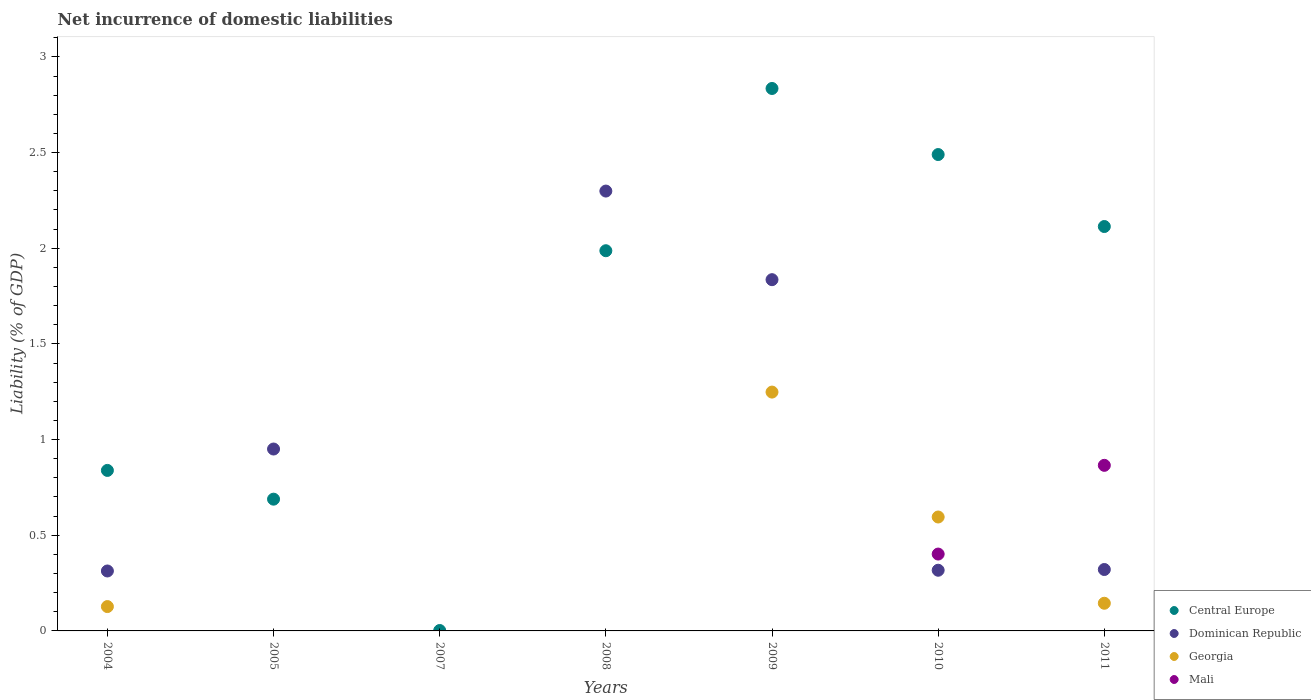What is the net incurrence of domestic liabilities in Dominican Republic in 2008?
Offer a terse response. 2.3. Across all years, what is the maximum net incurrence of domestic liabilities in Central Europe?
Provide a short and direct response. 2.83. Across all years, what is the minimum net incurrence of domestic liabilities in Central Europe?
Your answer should be very brief. 0. In which year was the net incurrence of domestic liabilities in Central Europe maximum?
Your response must be concise. 2009. What is the total net incurrence of domestic liabilities in Georgia in the graph?
Provide a succinct answer. 2.12. What is the difference between the net incurrence of domestic liabilities in Central Europe in 2005 and that in 2010?
Offer a very short reply. -1.8. What is the difference between the net incurrence of domestic liabilities in Central Europe in 2009 and the net incurrence of domestic liabilities in Dominican Republic in 2008?
Your answer should be very brief. 0.54. What is the average net incurrence of domestic liabilities in Georgia per year?
Ensure brevity in your answer.  0.3. In the year 2011, what is the difference between the net incurrence of domestic liabilities in Georgia and net incurrence of domestic liabilities in Dominican Republic?
Make the answer very short. -0.18. What is the ratio of the net incurrence of domestic liabilities in Central Europe in 2007 to that in 2009?
Give a very brief answer. 0. Is the net incurrence of domestic liabilities in Georgia in 2010 less than that in 2011?
Offer a terse response. No. Is the difference between the net incurrence of domestic liabilities in Georgia in 2009 and 2010 greater than the difference between the net incurrence of domestic liabilities in Dominican Republic in 2009 and 2010?
Give a very brief answer. No. What is the difference between the highest and the second highest net incurrence of domestic liabilities in Dominican Republic?
Provide a succinct answer. 0.46. What is the difference between the highest and the lowest net incurrence of domestic liabilities in Central Europe?
Offer a very short reply. 2.83. In how many years, is the net incurrence of domestic liabilities in Central Europe greater than the average net incurrence of domestic liabilities in Central Europe taken over all years?
Make the answer very short. 4. Does the net incurrence of domestic liabilities in Georgia monotonically increase over the years?
Offer a terse response. No. Is the net incurrence of domestic liabilities in Mali strictly greater than the net incurrence of domestic liabilities in Georgia over the years?
Provide a succinct answer. No. How many dotlines are there?
Ensure brevity in your answer.  4. What is the difference between two consecutive major ticks on the Y-axis?
Your answer should be compact. 0.5. Does the graph contain any zero values?
Your answer should be very brief. Yes. Does the graph contain grids?
Your answer should be very brief. No. Where does the legend appear in the graph?
Your answer should be very brief. Bottom right. How many legend labels are there?
Offer a terse response. 4. What is the title of the graph?
Provide a short and direct response. Net incurrence of domestic liabilities. What is the label or title of the Y-axis?
Ensure brevity in your answer.  Liability (% of GDP). What is the Liability (% of GDP) of Central Europe in 2004?
Make the answer very short. 0.84. What is the Liability (% of GDP) of Dominican Republic in 2004?
Ensure brevity in your answer.  0.31. What is the Liability (% of GDP) in Georgia in 2004?
Offer a very short reply. 0.13. What is the Liability (% of GDP) of Mali in 2004?
Your answer should be very brief. 0. What is the Liability (% of GDP) of Central Europe in 2005?
Your response must be concise. 0.69. What is the Liability (% of GDP) of Dominican Republic in 2005?
Your answer should be compact. 0.95. What is the Liability (% of GDP) of Georgia in 2005?
Offer a terse response. 0. What is the Liability (% of GDP) in Mali in 2005?
Provide a short and direct response. 0. What is the Liability (% of GDP) of Central Europe in 2007?
Offer a very short reply. 0. What is the Liability (% of GDP) in Georgia in 2007?
Keep it short and to the point. 0. What is the Liability (% of GDP) of Mali in 2007?
Your response must be concise. 0. What is the Liability (% of GDP) of Central Europe in 2008?
Keep it short and to the point. 1.99. What is the Liability (% of GDP) of Dominican Republic in 2008?
Offer a terse response. 2.3. What is the Liability (% of GDP) in Georgia in 2008?
Your answer should be very brief. 0. What is the Liability (% of GDP) of Mali in 2008?
Your answer should be compact. 0. What is the Liability (% of GDP) of Central Europe in 2009?
Provide a short and direct response. 2.83. What is the Liability (% of GDP) of Dominican Republic in 2009?
Your answer should be very brief. 1.84. What is the Liability (% of GDP) of Georgia in 2009?
Ensure brevity in your answer.  1.25. What is the Liability (% of GDP) of Central Europe in 2010?
Offer a terse response. 2.49. What is the Liability (% of GDP) of Dominican Republic in 2010?
Offer a very short reply. 0.32. What is the Liability (% of GDP) in Georgia in 2010?
Keep it short and to the point. 0.6. What is the Liability (% of GDP) of Mali in 2010?
Offer a terse response. 0.4. What is the Liability (% of GDP) of Central Europe in 2011?
Your answer should be compact. 2.11. What is the Liability (% of GDP) in Dominican Republic in 2011?
Make the answer very short. 0.32. What is the Liability (% of GDP) of Georgia in 2011?
Provide a short and direct response. 0.14. What is the Liability (% of GDP) of Mali in 2011?
Offer a very short reply. 0.87. Across all years, what is the maximum Liability (% of GDP) of Central Europe?
Your response must be concise. 2.83. Across all years, what is the maximum Liability (% of GDP) in Dominican Republic?
Ensure brevity in your answer.  2.3. Across all years, what is the maximum Liability (% of GDP) of Georgia?
Offer a very short reply. 1.25. Across all years, what is the maximum Liability (% of GDP) of Mali?
Offer a terse response. 0.87. Across all years, what is the minimum Liability (% of GDP) of Central Europe?
Offer a terse response. 0. What is the total Liability (% of GDP) of Central Europe in the graph?
Keep it short and to the point. 10.95. What is the total Liability (% of GDP) in Dominican Republic in the graph?
Offer a terse response. 6.04. What is the total Liability (% of GDP) of Georgia in the graph?
Offer a terse response. 2.12. What is the total Liability (% of GDP) of Mali in the graph?
Your answer should be compact. 1.27. What is the difference between the Liability (% of GDP) of Central Europe in 2004 and that in 2005?
Keep it short and to the point. 0.15. What is the difference between the Liability (% of GDP) in Dominican Republic in 2004 and that in 2005?
Keep it short and to the point. -0.64. What is the difference between the Liability (% of GDP) in Central Europe in 2004 and that in 2007?
Provide a succinct answer. 0.84. What is the difference between the Liability (% of GDP) of Central Europe in 2004 and that in 2008?
Keep it short and to the point. -1.15. What is the difference between the Liability (% of GDP) in Dominican Republic in 2004 and that in 2008?
Provide a succinct answer. -1.99. What is the difference between the Liability (% of GDP) of Central Europe in 2004 and that in 2009?
Give a very brief answer. -2. What is the difference between the Liability (% of GDP) in Dominican Republic in 2004 and that in 2009?
Your response must be concise. -1.52. What is the difference between the Liability (% of GDP) of Georgia in 2004 and that in 2009?
Offer a terse response. -1.12. What is the difference between the Liability (% of GDP) of Central Europe in 2004 and that in 2010?
Keep it short and to the point. -1.65. What is the difference between the Liability (% of GDP) of Dominican Republic in 2004 and that in 2010?
Give a very brief answer. -0. What is the difference between the Liability (% of GDP) of Georgia in 2004 and that in 2010?
Ensure brevity in your answer.  -0.47. What is the difference between the Liability (% of GDP) of Central Europe in 2004 and that in 2011?
Your response must be concise. -1.27. What is the difference between the Liability (% of GDP) in Dominican Republic in 2004 and that in 2011?
Keep it short and to the point. -0.01. What is the difference between the Liability (% of GDP) in Georgia in 2004 and that in 2011?
Your response must be concise. -0.02. What is the difference between the Liability (% of GDP) in Central Europe in 2005 and that in 2007?
Your answer should be compact. 0.69. What is the difference between the Liability (% of GDP) of Central Europe in 2005 and that in 2008?
Provide a succinct answer. -1.3. What is the difference between the Liability (% of GDP) of Dominican Republic in 2005 and that in 2008?
Make the answer very short. -1.35. What is the difference between the Liability (% of GDP) in Central Europe in 2005 and that in 2009?
Make the answer very short. -2.15. What is the difference between the Liability (% of GDP) of Dominican Republic in 2005 and that in 2009?
Your response must be concise. -0.89. What is the difference between the Liability (% of GDP) in Central Europe in 2005 and that in 2010?
Your answer should be compact. -1.8. What is the difference between the Liability (% of GDP) of Dominican Republic in 2005 and that in 2010?
Your answer should be compact. 0.63. What is the difference between the Liability (% of GDP) of Central Europe in 2005 and that in 2011?
Make the answer very short. -1.42. What is the difference between the Liability (% of GDP) in Dominican Republic in 2005 and that in 2011?
Ensure brevity in your answer.  0.63. What is the difference between the Liability (% of GDP) of Central Europe in 2007 and that in 2008?
Ensure brevity in your answer.  -1.98. What is the difference between the Liability (% of GDP) of Central Europe in 2007 and that in 2009?
Your response must be concise. -2.83. What is the difference between the Liability (% of GDP) of Central Europe in 2007 and that in 2010?
Offer a terse response. -2.49. What is the difference between the Liability (% of GDP) of Central Europe in 2007 and that in 2011?
Provide a succinct answer. -2.11. What is the difference between the Liability (% of GDP) of Central Europe in 2008 and that in 2009?
Your answer should be compact. -0.85. What is the difference between the Liability (% of GDP) of Dominican Republic in 2008 and that in 2009?
Ensure brevity in your answer.  0.46. What is the difference between the Liability (% of GDP) in Central Europe in 2008 and that in 2010?
Your answer should be compact. -0.5. What is the difference between the Liability (% of GDP) in Dominican Republic in 2008 and that in 2010?
Make the answer very short. 1.98. What is the difference between the Liability (% of GDP) in Central Europe in 2008 and that in 2011?
Offer a terse response. -0.13. What is the difference between the Liability (% of GDP) in Dominican Republic in 2008 and that in 2011?
Provide a short and direct response. 1.98. What is the difference between the Liability (% of GDP) of Central Europe in 2009 and that in 2010?
Keep it short and to the point. 0.35. What is the difference between the Liability (% of GDP) of Dominican Republic in 2009 and that in 2010?
Make the answer very short. 1.52. What is the difference between the Liability (% of GDP) in Georgia in 2009 and that in 2010?
Provide a succinct answer. 0.65. What is the difference between the Liability (% of GDP) in Central Europe in 2009 and that in 2011?
Provide a succinct answer. 0.72. What is the difference between the Liability (% of GDP) of Dominican Republic in 2009 and that in 2011?
Provide a succinct answer. 1.51. What is the difference between the Liability (% of GDP) in Georgia in 2009 and that in 2011?
Ensure brevity in your answer.  1.1. What is the difference between the Liability (% of GDP) in Central Europe in 2010 and that in 2011?
Give a very brief answer. 0.38. What is the difference between the Liability (% of GDP) of Dominican Republic in 2010 and that in 2011?
Your answer should be compact. -0. What is the difference between the Liability (% of GDP) of Georgia in 2010 and that in 2011?
Offer a very short reply. 0.45. What is the difference between the Liability (% of GDP) in Mali in 2010 and that in 2011?
Offer a very short reply. -0.46. What is the difference between the Liability (% of GDP) of Central Europe in 2004 and the Liability (% of GDP) of Dominican Republic in 2005?
Give a very brief answer. -0.11. What is the difference between the Liability (% of GDP) of Central Europe in 2004 and the Liability (% of GDP) of Dominican Republic in 2008?
Offer a very short reply. -1.46. What is the difference between the Liability (% of GDP) of Central Europe in 2004 and the Liability (% of GDP) of Dominican Republic in 2009?
Ensure brevity in your answer.  -1. What is the difference between the Liability (% of GDP) of Central Europe in 2004 and the Liability (% of GDP) of Georgia in 2009?
Offer a very short reply. -0.41. What is the difference between the Liability (% of GDP) in Dominican Republic in 2004 and the Liability (% of GDP) in Georgia in 2009?
Provide a short and direct response. -0.93. What is the difference between the Liability (% of GDP) of Central Europe in 2004 and the Liability (% of GDP) of Dominican Republic in 2010?
Provide a short and direct response. 0.52. What is the difference between the Liability (% of GDP) of Central Europe in 2004 and the Liability (% of GDP) of Georgia in 2010?
Keep it short and to the point. 0.24. What is the difference between the Liability (% of GDP) in Central Europe in 2004 and the Liability (% of GDP) in Mali in 2010?
Give a very brief answer. 0.44. What is the difference between the Liability (% of GDP) in Dominican Republic in 2004 and the Liability (% of GDP) in Georgia in 2010?
Offer a very short reply. -0.28. What is the difference between the Liability (% of GDP) of Dominican Republic in 2004 and the Liability (% of GDP) of Mali in 2010?
Give a very brief answer. -0.09. What is the difference between the Liability (% of GDP) of Georgia in 2004 and the Liability (% of GDP) of Mali in 2010?
Your answer should be compact. -0.27. What is the difference between the Liability (% of GDP) in Central Europe in 2004 and the Liability (% of GDP) in Dominican Republic in 2011?
Your response must be concise. 0.52. What is the difference between the Liability (% of GDP) in Central Europe in 2004 and the Liability (% of GDP) in Georgia in 2011?
Provide a succinct answer. 0.69. What is the difference between the Liability (% of GDP) of Central Europe in 2004 and the Liability (% of GDP) of Mali in 2011?
Your response must be concise. -0.03. What is the difference between the Liability (% of GDP) of Dominican Republic in 2004 and the Liability (% of GDP) of Georgia in 2011?
Your response must be concise. 0.17. What is the difference between the Liability (% of GDP) in Dominican Republic in 2004 and the Liability (% of GDP) in Mali in 2011?
Make the answer very short. -0.55. What is the difference between the Liability (% of GDP) of Georgia in 2004 and the Liability (% of GDP) of Mali in 2011?
Your response must be concise. -0.74. What is the difference between the Liability (% of GDP) in Central Europe in 2005 and the Liability (% of GDP) in Dominican Republic in 2008?
Make the answer very short. -1.61. What is the difference between the Liability (% of GDP) in Central Europe in 2005 and the Liability (% of GDP) in Dominican Republic in 2009?
Your response must be concise. -1.15. What is the difference between the Liability (% of GDP) in Central Europe in 2005 and the Liability (% of GDP) in Georgia in 2009?
Your response must be concise. -0.56. What is the difference between the Liability (% of GDP) in Dominican Republic in 2005 and the Liability (% of GDP) in Georgia in 2009?
Your answer should be compact. -0.3. What is the difference between the Liability (% of GDP) in Central Europe in 2005 and the Liability (% of GDP) in Dominican Republic in 2010?
Give a very brief answer. 0.37. What is the difference between the Liability (% of GDP) of Central Europe in 2005 and the Liability (% of GDP) of Georgia in 2010?
Give a very brief answer. 0.09. What is the difference between the Liability (% of GDP) of Central Europe in 2005 and the Liability (% of GDP) of Mali in 2010?
Your response must be concise. 0.29. What is the difference between the Liability (% of GDP) of Dominican Republic in 2005 and the Liability (% of GDP) of Georgia in 2010?
Make the answer very short. 0.36. What is the difference between the Liability (% of GDP) in Dominican Republic in 2005 and the Liability (% of GDP) in Mali in 2010?
Provide a short and direct response. 0.55. What is the difference between the Liability (% of GDP) of Central Europe in 2005 and the Liability (% of GDP) of Dominican Republic in 2011?
Your answer should be very brief. 0.37. What is the difference between the Liability (% of GDP) of Central Europe in 2005 and the Liability (% of GDP) of Georgia in 2011?
Your response must be concise. 0.54. What is the difference between the Liability (% of GDP) in Central Europe in 2005 and the Liability (% of GDP) in Mali in 2011?
Keep it short and to the point. -0.18. What is the difference between the Liability (% of GDP) of Dominican Republic in 2005 and the Liability (% of GDP) of Georgia in 2011?
Make the answer very short. 0.81. What is the difference between the Liability (% of GDP) in Dominican Republic in 2005 and the Liability (% of GDP) in Mali in 2011?
Your answer should be compact. 0.09. What is the difference between the Liability (% of GDP) of Central Europe in 2007 and the Liability (% of GDP) of Dominican Republic in 2008?
Your answer should be very brief. -2.3. What is the difference between the Liability (% of GDP) in Central Europe in 2007 and the Liability (% of GDP) in Dominican Republic in 2009?
Provide a short and direct response. -1.83. What is the difference between the Liability (% of GDP) of Central Europe in 2007 and the Liability (% of GDP) of Georgia in 2009?
Offer a terse response. -1.25. What is the difference between the Liability (% of GDP) of Central Europe in 2007 and the Liability (% of GDP) of Dominican Republic in 2010?
Ensure brevity in your answer.  -0.32. What is the difference between the Liability (% of GDP) of Central Europe in 2007 and the Liability (% of GDP) of Georgia in 2010?
Offer a terse response. -0.59. What is the difference between the Liability (% of GDP) of Central Europe in 2007 and the Liability (% of GDP) of Mali in 2010?
Offer a very short reply. -0.4. What is the difference between the Liability (% of GDP) of Central Europe in 2007 and the Liability (% of GDP) of Dominican Republic in 2011?
Your answer should be very brief. -0.32. What is the difference between the Liability (% of GDP) of Central Europe in 2007 and the Liability (% of GDP) of Georgia in 2011?
Make the answer very short. -0.14. What is the difference between the Liability (% of GDP) of Central Europe in 2007 and the Liability (% of GDP) of Mali in 2011?
Offer a terse response. -0.86. What is the difference between the Liability (% of GDP) of Central Europe in 2008 and the Liability (% of GDP) of Dominican Republic in 2009?
Make the answer very short. 0.15. What is the difference between the Liability (% of GDP) of Central Europe in 2008 and the Liability (% of GDP) of Georgia in 2009?
Your response must be concise. 0.74. What is the difference between the Liability (% of GDP) of Dominican Republic in 2008 and the Liability (% of GDP) of Georgia in 2009?
Your response must be concise. 1.05. What is the difference between the Liability (% of GDP) of Central Europe in 2008 and the Liability (% of GDP) of Dominican Republic in 2010?
Your answer should be very brief. 1.67. What is the difference between the Liability (% of GDP) in Central Europe in 2008 and the Liability (% of GDP) in Georgia in 2010?
Keep it short and to the point. 1.39. What is the difference between the Liability (% of GDP) in Central Europe in 2008 and the Liability (% of GDP) in Mali in 2010?
Ensure brevity in your answer.  1.59. What is the difference between the Liability (% of GDP) in Dominican Republic in 2008 and the Liability (% of GDP) in Georgia in 2010?
Provide a succinct answer. 1.7. What is the difference between the Liability (% of GDP) in Dominican Republic in 2008 and the Liability (% of GDP) in Mali in 2010?
Your response must be concise. 1.9. What is the difference between the Liability (% of GDP) in Central Europe in 2008 and the Liability (% of GDP) in Dominican Republic in 2011?
Provide a succinct answer. 1.67. What is the difference between the Liability (% of GDP) of Central Europe in 2008 and the Liability (% of GDP) of Georgia in 2011?
Keep it short and to the point. 1.84. What is the difference between the Liability (% of GDP) in Central Europe in 2008 and the Liability (% of GDP) in Mali in 2011?
Ensure brevity in your answer.  1.12. What is the difference between the Liability (% of GDP) in Dominican Republic in 2008 and the Liability (% of GDP) in Georgia in 2011?
Provide a succinct answer. 2.15. What is the difference between the Liability (% of GDP) in Dominican Republic in 2008 and the Liability (% of GDP) in Mali in 2011?
Give a very brief answer. 1.43. What is the difference between the Liability (% of GDP) of Central Europe in 2009 and the Liability (% of GDP) of Dominican Republic in 2010?
Offer a terse response. 2.52. What is the difference between the Liability (% of GDP) in Central Europe in 2009 and the Liability (% of GDP) in Georgia in 2010?
Provide a short and direct response. 2.24. What is the difference between the Liability (% of GDP) in Central Europe in 2009 and the Liability (% of GDP) in Mali in 2010?
Make the answer very short. 2.43. What is the difference between the Liability (% of GDP) of Dominican Republic in 2009 and the Liability (% of GDP) of Georgia in 2010?
Your answer should be compact. 1.24. What is the difference between the Liability (% of GDP) in Dominican Republic in 2009 and the Liability (% of GDP) in Mali in 2010?
Your response must be concise. 1.43. What is the difference between the Liability (% of GDP) in Georgia in 2009 and the Liability (% of GDP) in Mali in 2010?
Your answer should be very brief. 0.85. What is the difference between the Liability (% of GDP) of Central Europe in 2009 and the Liability (% of GDP) of Dominican Republic in 2011?
Provide a succinct answer. 2.51. What is the difference between the Liability (% of GDP) of Central Europe in 2009 and the Liability (% of GDP) of Georgia in 2011?
Your answer should be compact. 2.69. What is the difference between the Liability (% of GDP) in Central Europe in 2009 and the Liability (% of GDP) in Mali in 2011?
Ensure brevity in your answer.  1.97. What is the difference between the Liability (% of GDP) in Dominican Republic in 2009 and the Liability (% of GDP) in Georgia in 2011?
Your response must be concise. 1.69. What is the difference between the Liability (% of GDP) of Dominican Republic in 2009 and the Liability (% of GDP) of Mali in 2011?
Provide a short and direct response. 0.97. What is the difference between the Liability (% of GDP) in Georgia in 2009 and the Liability (% of GDP) in Mali in 2011?
Give a very brief answer. 0.38. What is the difference between the Liability (% of GDP) in Central Europe in 2010 and the Liability (% of GDP) in Dominican Republic in 2011?
Your answer should be compact. 2.17. What is the difference between the Liability (% of GDP) of Central Europe in 2010 and the Liability (% of GDP) of Georgia in 2011?
Give a very brief answer. 2.35. What is the difference between the Liability (% of GDP) in Central Europe in 2010 and the Liability (% of GDP) in Mali in 2011?
Your answer should be compact. 1.62. What is the difference between the Liability (% of GDP) in Dominican Republic in 2010 and the Liability (% of GDP) in Georgia in 2011?
Your answer should be very brief. 0.17. What is the difference between the Liability (% of GDP) in Dominican Republic in 2010 and the Liability (% of GDP) in Mali in 2011?
Offer a very short reply. -0.55. What is the difference between the Liability (% of GDP) of Georgia in 2010 and the Liability (% of GDP) of Mali in 2011?
Your response must be concise. -0.27. What is the average Liability (% of GDP) in Central Europe per year?
Ensure brevity in your answer.  1.56. What is the average Liability (% of GDP) of Dominican Republic per year?
Offer a terse response. 0.86. What is the average Liability (% of GDP) of Georgia per year?
Offer a terse response. 0.3. What is the average Liability (% of GDP) in Mali per year?
Your response must be concise. 0.18. In the year 2004, what is the difference between the Liability (% of GDP) of Central Europe and Liability (% of GDP) of Dominican Republic?
Make the answer very short. 0.53. In the year 2004, what is the difference between the Liability (% of GDP) in Central Europe and Liability (% of GDP) in Georgia?
Offer a very short reply. 0.71. In the year 2004, what is the difference between the Liability (% of GDP) in Dominican Republic and Liability (% of GDP) in Georgia?
Keep it short and to the point. 0.19. In the year 2005, what is the difference between the Liability (% of GDP) of Central Europe and Liability (% of GDP) of Dominican Republic?
Provide a succinct answer. -0.26. In the year 2008, what is the difference between the Liability (% of GDP) in Central Europe and Liability (% of GDP) in Dominican Republic?
Your response must be concise. -0.31. In the year 2009, what is the difference between the Liability (% of GDP) in Central Europe and Liability (% of GDP) in Georgia?
Ensure brevity in your answer.  1.59. In the year 2009, what is the difference between the Liability (% of GDP) of Dominican Republic and Liability (% of GDP) of Georgia?
Keep it short and to the point. 0.59. In the year 2010, what is the difference between the Liability (% of GDP) in Central Europe and Liability (% of GDP) in Dominican Republic?
Your response must be concise. 2.17. In the year 2010, what is the difference between the Liability (% of GDP) of Central Europe and Liability (% of GDP) of Georgia?
Your answer should be compact. 1.89. In the year 2010, what is the difference between the Liability (% of GDP) in Central Europe and Liability (% of GDP) in Mali?
Make the answer very short. 2.09. In the year 2010, what is the difference between the Liability (% of GDP) in Dominican Republic and Liability (% of GDP) in Georgia?
Give a very brief answer. -0.28. In the year 2010, what is the difference between the Liability (% of GDP) in Dominican Republic and Liability (% of GDP) in Mali?
Offer a terse response. -0.08. In the year 2010, what is the difference between the Liability (% of GDP) in Georgia and Liability (% of GDP) in Mali?
Your response must be concise. 0.19. In the year 2011, what is the difference between the Liability (% of GDP) in Central Europe and Liability (% of GDP) in Dominican Republic?
Your response must be concise. 1.79. In the year 2011, what is the difference between the Liability (% of GDP) of Central Europe and Liability (% of GDP) of Georgia?
Keep it short and to the point. 1.97. In the year 2011, what is the difference between the Liability (% of GDP) in Central Europe and Liability (% of GDP) in Mali?
Provide a succinct answer. 1.25. In the year 2011, what is the difference between the Liability (% of GDP) in Dominican Republic and Liability (% of GDP) in Georgia?
Your response must be concise. 0.18. In the year 2011, what is the difference between the Liability (% of GDP) of Dominican Republic and Liability (% of GDP) of Mali?
Provide a short and direct response. -0.54. In the year 2011, what is the difference between the Liability (% of GDP) in Georgia and Liability (% of GDP) in Mali?
Provide a short and direct response. -0.72. What is the ratio of the Liability (% of GDP) of Central Europe in 2004 to that in 2005?
Give a very brief answer. 1.22. What is the ratio of the Liability (% of GDP) in Dominican Republic in 2004 to that in 2005?
Provide a short and direct response. 0.33. What is the ratio of the Liability (% of GDP) of Central Europe in 2004 to that in 2007?
Your answer should be very brief. 387.48. What is the ratio of the Liability (% of GDP) of Central Europe in 2004 to that in 2008?
Provide a short and direct response. 0.42. What is the ratio of the Liability (% of GDP) in Dominican Republic in 2004 to that in 2008?
Give a very brief answer. 0.14. What is the ratio of the Liability (% of GDP) of Central Europe in 2004 to that in 2009?
Your answer should be very brief. 0.3. What is the ratio of the Liability (% of GDP) of Dominican Republic in 2004 to that in 2009?
Your answer should be compact. 0.17. What is the ratio of the Liability (% of GDP) of Georgia in 2004 to that in 2009?
Provide a succinct answer. 0.1. What is the ratio of the Liability (% of GDP) in Central Europe in 2004 to that in 2010?
Keep it short and to the point. 0.34. What is the ratio of the Liability (% of GDP) in Dominican Republic in 2004 to that in 2010?
Provide a short and direct response. 0.99. What is the ratio of the Liability (% of GDP) in Georgia in 2004 to that in 2010?
Your response must be concise. 0.21. What is the ratio of the Liability (% of GDP) of Central Europe in 2004 to that in 2011?
Offer a terse response. 0.4. What is the ratio of the Liability (% of GDP) in Georgia in 2004 to that in 2011?
Your answer should be compact. 0.88. What is the ratio of the Liability (% of GDP) in Central Europe in 2005 to that in 2007?
Your answer should be compact. 318.09. What is the ratio of the Liability (% of GDP) of Central Europe in 2005 to that in 2008?
Your answer should be compact. 0.35. What is the ratio of the Liability (% of GDP) in Dominican Republic in 2005 to that in 2008?
Provide a short and direct response. 0.41. What is the ratio of the Liability (% of GDP) in Central Europe in 2005 to that in 2009?
Provide a short and direct response. 0.24. What is the ratio of the Liability (% of GDP) of Dominican Republic in 2005 to that in 2009?
Keep it short and to the point. 0.52. What is the ratio of the Liability (% of GDP) of Central Europe in 2005 to that in 2010?
Your answer should be very brief. 0.28. What is the ratio of the Liability (% of GDP) of Dominican Republic in 2005 to that in 2010?
Your answer should be compact. 3. What is the ratio of the Liability (% of GDP) in Central Europe in 2005 to that in 2011?
Make the answer very short. 0.33. What is the ratio of the Liability (% of GDP) of Dominican Republic in 2005 to that in 2011?
Keep it short and to the point. 2.96. What is the ratio of the Liability (% of GDP) in Central Europe in 2007 to that in 2008?
Your response must be concise. 0. What is the ratio of the Liability (% of GDP) of Central Europe in 2007 to that in 2009?
Make the answer very short. 0. What is the ratio of the Liability (% of GDP) of Central Europe in 2007 to that in 2010?
Offer a very short reply. 0. What is the ratio of the Liability (% of GDP) of Central Europe in 2007 to that in 2011?
Keep it short and to the point. 0. What is the ratio of the Liability (% of GDP) of Central Europe in 2008 to that in 2009?
Offer a very short reply. 0.7. What is the ratio of the Liability (% of GDP) in Dominican Republic in 2008 to that in 2009?
Your answer should be very brief. 1.25. What is the ratio of the Liability (% of GDP) of Central Europe in 2008 to that in 2010?
Ensure brevity in your answer.  0.8. What is the ratio of the Liability (% of GDP) in Dominican Republic in 2008 to that in 2010?
Give a very brief answer. 7.25. What is the ratio of the Liability (% of GDP) in Central Europe in 2008 to that in 2011?
Your answer should be compact. 0.94. What is the ratio of the Liability (% of GDP) of Dominican Republic in 2008 to that in 2011?
Offer a terse response. 7.16. What is the ratio of the Liability (% of GDP) of Central Europe in 2009 to that in 2010?
Your answer should be very brief. 1.14. What is the ratio of the Liability (% of GDP) of Dominican Republic in 2009 to that in 2010?
Keep it short and to the point. 5.79. What is the ratio of the Liability (% of GDP) in Georgia in 2009 to that in 2010?
Ensure brevity in your answer.  2.1. What is the ratio of the Liability (% of GDP) of Central Europe in 2009 to that in 2011?
Keep it short and to the point. 1.34. What is the ratio of the Liability (% of GDP) of Dominican Republic in 2009 to that in 2011?
Give a very brief answer. 5.72. What is the ratio of the Liability (% of GDP) in Georgia in 2009 to that in 2011?
Offer a terse response. 8.63. What is the ratio of the Liability (% of GDP) in Central Europe in 2010 to that in 2011?
Give a very brief answer. 1.18. What is the ratio of the Liability (% of GDP) in Georgia in 2010 to that in 2011?
Your response must be concise. 4.12. What is the ratio of the Liability (% of GDP) in Mali in 2010 to that in 2011?
Give a very brief answer. 0.46. What is the difference between the highest and the second highest Liability (% of GDP) in Central Europe?
Your answer should be compact. 0.35. What is the difference between the highest and the second highest Liability (% of GDP) in Dominican Republic?
Your answer should be very brief. 0.46. What is the difference between the highest and the second highest Liability (% of GDP) in Georgia?
Ensure brevity in your answer.  0.65. What is the difference between the highest and the lowest Liability (% of GDP) of Central Europe?
Keep it short and to the point. 2.83. What is the difference between the highest and the lowest Liability (% of GDP) in Dominican Republic?
Your answer should be very brief. 2.3. What is the difference between the highest and the lowest Liability (% of GDP) in Georgia?
Offer a very short reply. 1.25. What is the difference between the highest and the lowest Liability (% of GDP) in Mali?
Ensure brevity in your answer.  0.87. 